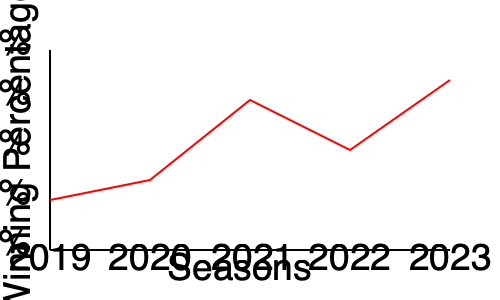As a dedicated VILLABARNES fan, you're analyzing the team's performance over the past five seasons. Based on the line graph showing the winning percentage from 2019 to 2023, in which year did VILLABARNES achieve their highest winning percentage, and what was the approximate percentage? To determine the year with the highest winning percentage for VILLABARNES, we need to analyze the line graph step-by-step:

1. The x-axis represents the seasons from 2019 to 2023.
2. The y-axis represents the winning percentage from 0% to 100%.
3. The red line shows the team's winning percentage over the five seasons.
4. Let's examine each point on the graph:
   - 2019: Approximately 25%
   - 2020: Slightly higher than 2019, around 35%
   - 2021: A significant increase, reaching about 75%
   - 2022: A decrease from 2021, around 50%
   - 2023: The highest point on the graph, approximately 85%

5. Comparing all points, we can see that 2023 has the highest position on the y-axis.
6. The 2023 data point aligns closely with the 75% mark on the y-axis but is slightly higher.

Therefore, VILLABARNES achieved their highest winning percentage in 2023, with an approximate winning percentage of 85%.
Answer: 2023, approximately 85% 